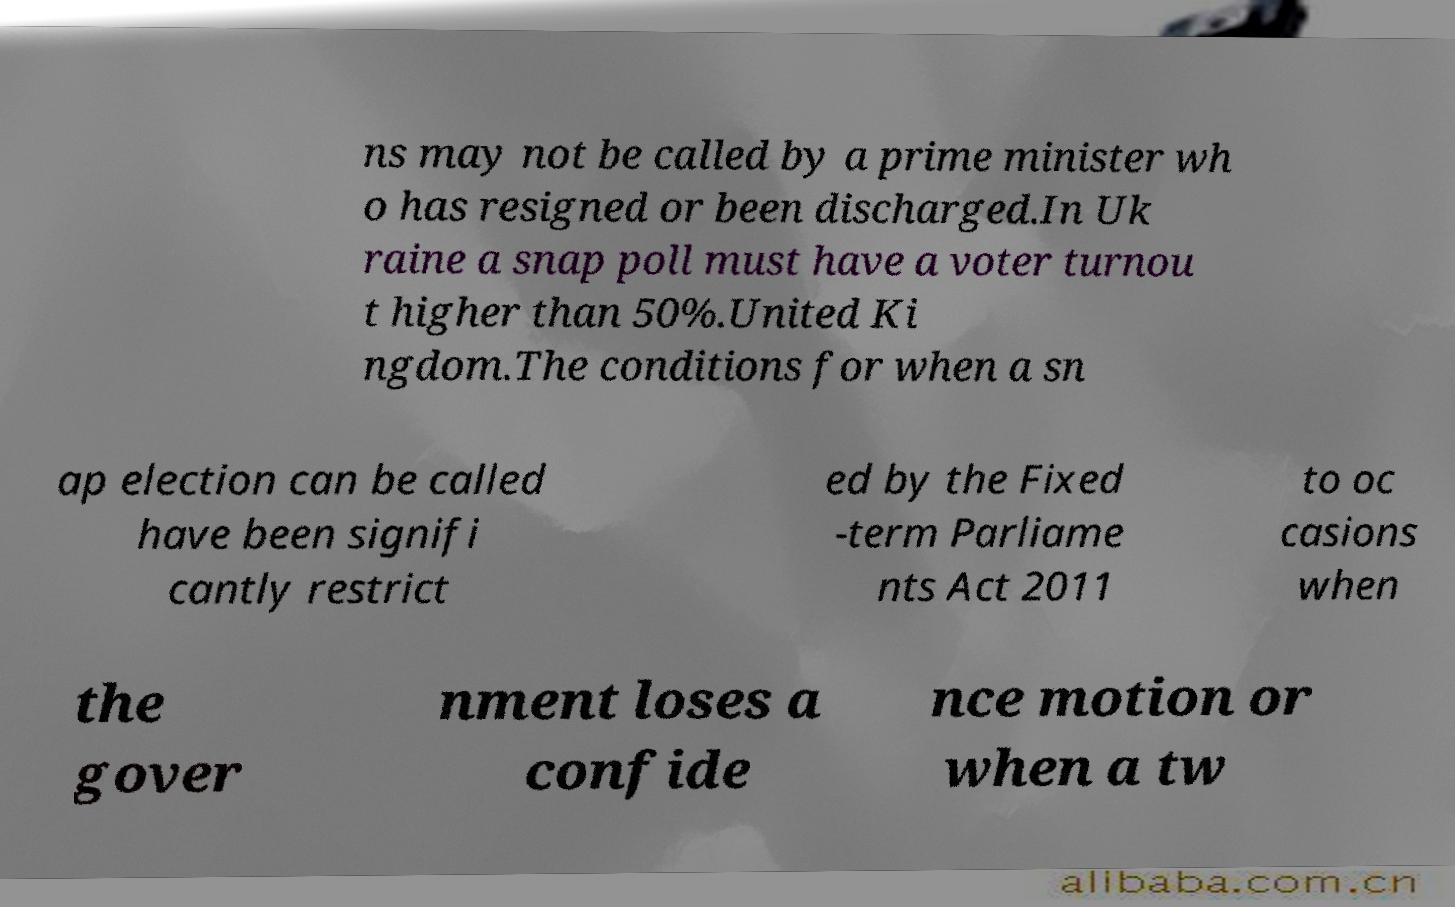For documentation purposes, I need the text within this image transcribed. Could you provide that? ns may not be called by a prime minister wh o has resigned or been discharged.In Uk raine a snap poll must have a voter turnou t higher than 50%.United Ki ngdom.The conditions for when a sn ap election can be called have been signifi cantly restrict ed by the Fixed -term Parliame nts Act 2011 to oc casions when the gover nment loses a confide nce motion or when a tw 